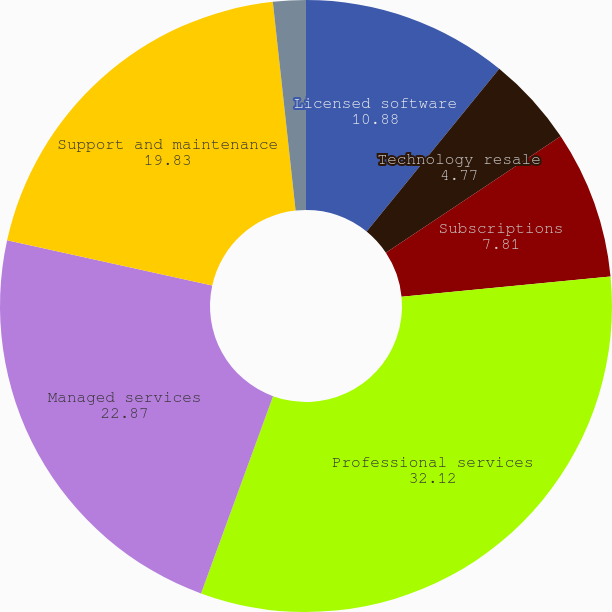<chart> <loc_0><loc_0><loc_500><loc_500><pie_chart><fcel>Licensed software<fcel>Technology resale<fcel>Subscriptions<fcel>Professional services<fcel>Managed services<fcel>Support and maintenance<fcel>Reimbursed travel<nl><fcel>10.88%<fcel>4.77%<fcel>7.81%<fcel>32.12%<fcel>22.87%<fcel>19.83%<fcel>1.73%<nl></chart> 